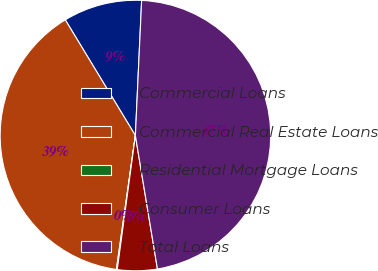<chart> <loc_0><loc_0><loc_500><loc_500><pie_chart><fcel>Commercial Loans<fcel>Commercial Real Estate Loans<fcel>Residential Mortgage Loans<fcel>Consumer Loans<fcel>Total Loans<nl><fcel>9.41%<fcel>39.09%<fcel>0.1%<fcel>4.75%<fcel>46.66%<nl></chart> 